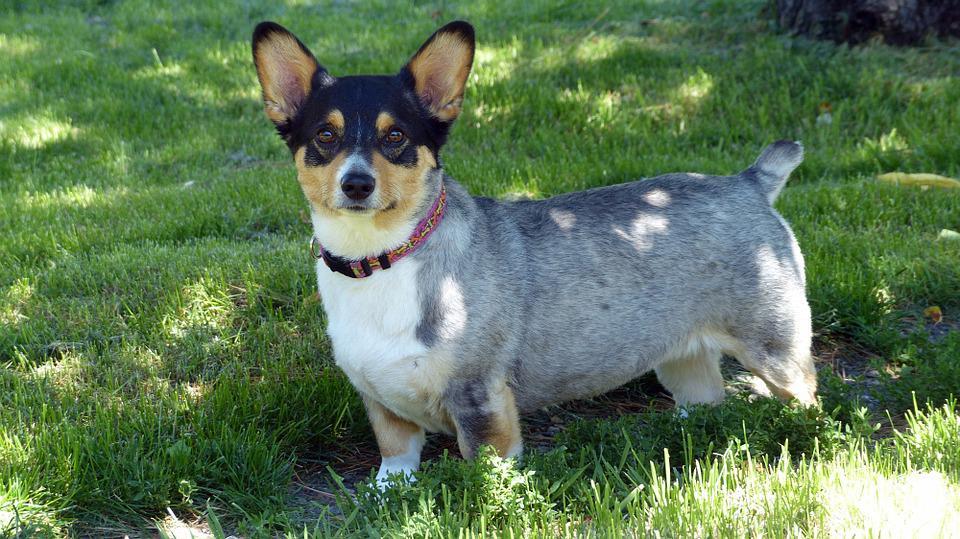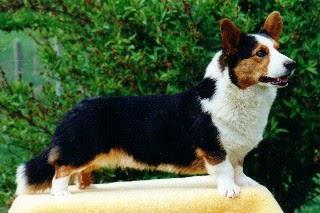The first image is the image on the left, the second image is the image on the right. Assess this claim about the two images: "the left image has a sitting dog with its' tongue out". Correct or not? Answer yes or no. No. The first image is the image on the left, the second image is the image on the right. Evaluate the accuracy of this statement regarding the images: "One dog is looking to the right.". Is it true? Answer yes or no. Yes. 